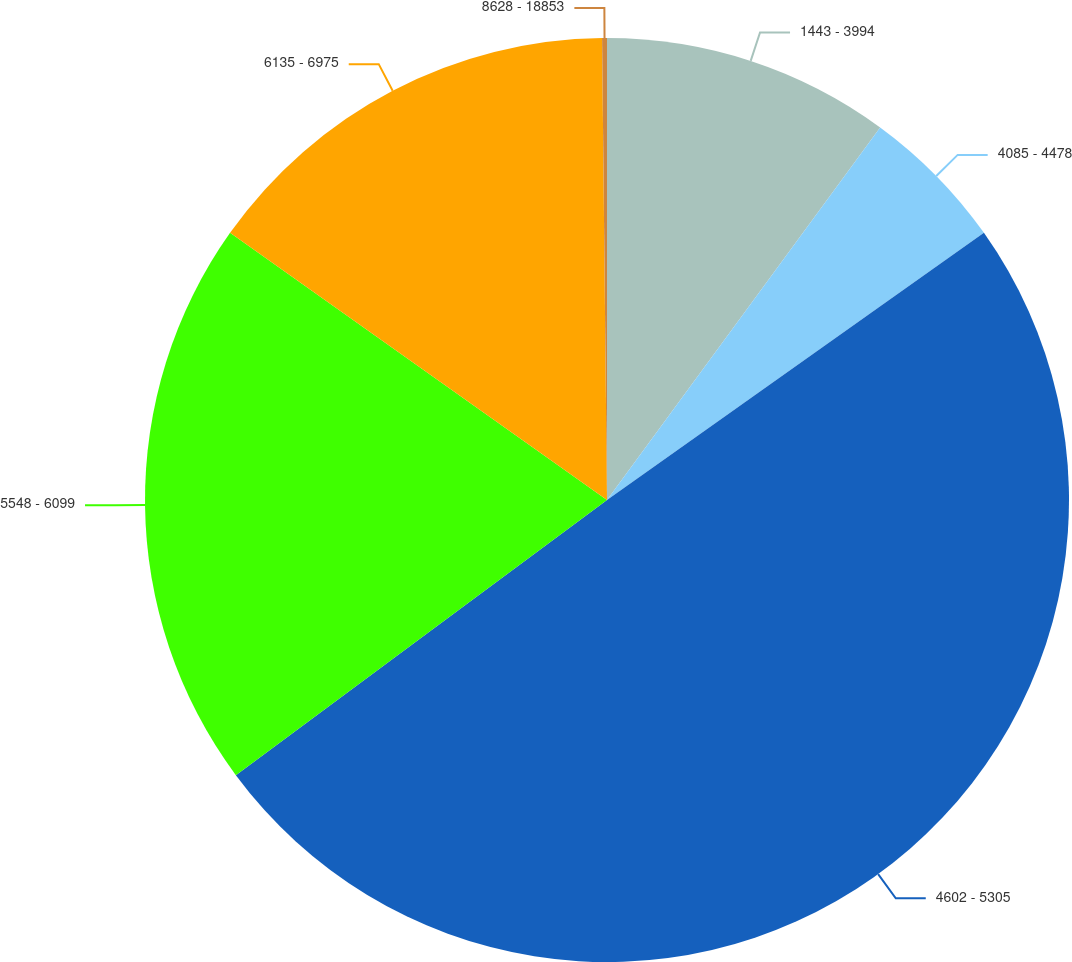Convert chart. <chart><loc_0><loc_0><loc_500><loc_500><pie_chart><fcel>1443 - 3994<fcel>4085 - 4478<fcel>4602 - 5305<fcel>5548 - 6099<fcel>6135 - 6975<fcel>8628 - 18853<nl><fcel>10.07%<fcel>5.12%<fcel>49.67%<fcel>19.97%<fcel>15.02%<fcel>0.17%<nl></chart> 